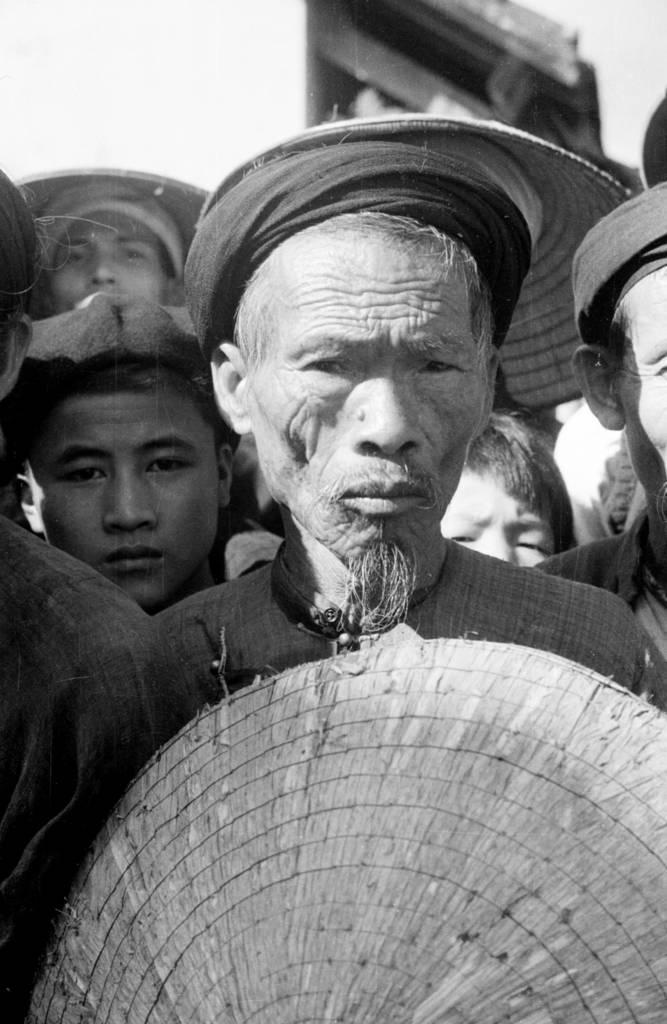How would you summarize this image in a sentence or two? This is a black and white image and here we can see people and are wearing hats and we can see an object, at the bottom. 